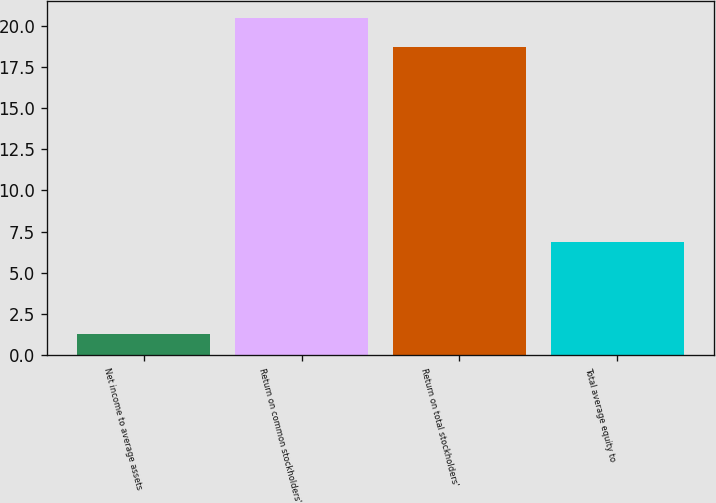Convert chart to OTSL. <chart><loc_0><loc_0><loc_500><loc_500><bar_chart><fcel>Net income to average assets<fcel>Return on common stockholders'<fcel>Return on total stockholders'<fcel>Total average equity to<nl><fcel>1.28<fcel>20.45<fcel>18.7<fcel>6.87<nl></chart> 